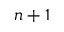<formula> <loc_0><loc_0><loc_500><loc_500>n + 1</formula> 